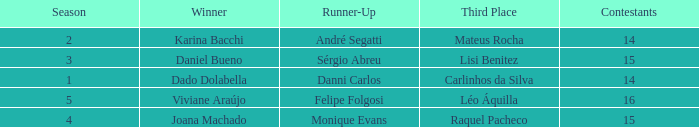In what season did Raquel Pacheco finish in third place? 4.0. 